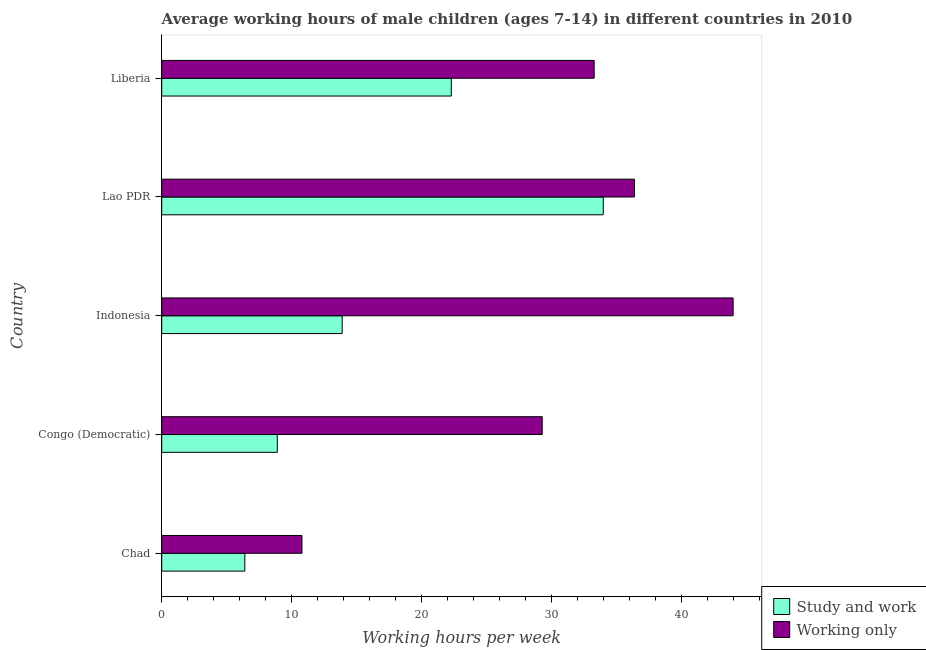How many different coloured bars are there?
Provide a succinct answer. 2. How many bars are there on the 4th tick from the top?
Make the answer very short. 2. How many bars are there on the 2nd tick from the bottom?
Your response must be concise. 2. What is the label of the 5th group of bars from the top?
Your answer should be very brief. Chad. What is the average working hour of children involved in only work in Chad?
Provide a succinct answer. 10.8. Across all countries, what is the minimum average working hour of children involved in only work?
Your response must be concise. 10.8. In which country was the average working hour of children involved in study and work maximum?
Make the answer very short. Lao PDR. In which country was the average working hour of children involved in study and work minimum?
Give a very brief answer. Chad. What is the total average working hour of children involved in study and work in the graph?
Your answer should be very brief. 85.5. What is the difference between the average working hour of children involved in study and work in Chad and that in Liberia?
Give a very brief answer. -15.9. What is the difference between the average working hour of children involved in only work in Congo (Democratic) and the average working hour of children involved in study and work in Indonesia?
Make the answer very short. 15.4. What is the average average working hour of children involved in only work per country?
Your answer should be compact. 30.76. What is the difference between the average working hour of children involved in only work and average working hour of children involved in study and work in Indonesia?
Ensure brevity in your answer.  30.1. In how many countries, is the average working hour of children involved in only work greater than 42 hours?
Give a very brief answer. 1. What is the ratio of the average working hour of children involved in study and work in Chad to that in Liberia?
Offer a very short reply. 0.29. Is the average working hour of children involved in study and work in Congo (Democratic) less than that in Indonesia?
Offer a very short reply. Yes. What is the difference between the highest and the lowest average working hour of children involved in only work?
Make the answer very short. 33.2. In how many countries, is the average working hour of children involved in only work greater than the average average working hour of children involved in only work taken over all countries?
Your answer should be very brief. 3. What does the 2nd bar from the top in Lao PDR represents?
Provide a short and direct response. Study and work. What does the 2nd bar from the bottom in Congo (Democratic) represents?
Make the answer very short. Working only. How many bars are there?
Make the answer very short. 10. What is the difference between two consecutive major ticks on the X-axis?
Provide a succinct answer. 10. Are the values on the major ticks of X-axis written in scientific E-notation?
Make the answer very short. No. Does the graph contain any zero values?
Provide a succinct answer. No. Does the graph contain grids?
Offer a terse response. No. What is the title of the graph?
Ensure brevity in your answer.  Average working hours of male children (ages 7-14) in different countries in 2010. Does "Methane" appear as one of the legend labels in the graph?
Make the answer very short. No. What is the label or title of the X-axis?
Give a very brief answer. Working hours per week. What is the Working hours per week of Study and work in Chad?
Keep it short and to the point. 6.4. What is the Working hours per week in Working only in Chad?
Your response must be concise. 10.8. What is the Working hours per week of Working only in Congo (Democratic)?
Your answer should be very brief. 29.3. What is the Working hours per week in Working only in Indonesia?
Your response must be concise. 44. What is the Working hours per week in Working only in Lao PDR?
Your response must be concise. 36.4. What is the Working hours per week in Study and work in Liberia?
Offer a very short reply. 22.3. What is the Working hours per week in Working only in Liberia?
Make the answer very short. 33.3. Across all countries, what is the minimum Working hours per week in Study and work?
Provide a short and direct response. 6.4. What is the total Working hours per week in Study and work in the graph?
Keep it short and to the point. 85.5. What is the total Working hours per week in Working only in the graph?
Provide a short and direct response. 153.8. What is the difference between the Working hours per week of Working only in Chad and that in Congo (Democratic)?
Offer a very short reply. -18.5. What is the difference between the Working hours per week in Study and work in Chad and that in Indonesia?
Your response must be concise. -7.5. What is the difference between the Working hours per week of Working only in Chad and that in Indonesia?
Your answer should be compact. -33.2. What is the difference between the Working hours per week in Study and work in Chad and that in Lao PDR?
Ensure brevity in your answer.  -27.6. What is the difference between the Working hours per week of Working only in Chad and that in Lao PDR?
Offer a terse response. -25.6. What is the difference between the Working hours per week in Study and work in Chad and that in Liberia?
Make the answer very short. -15.9. What is the difference between the Working hours per week of Working only in Chad and that in Liberia?
Your answer should be compact. -22.5. What is the difference between the Working hours per week of Study and work in Congo (Democratic) and that in Indonesia?
Offer a terse response. -5. What is the difference between the Working hours per week of Working only in Congo (Democratic) and that in Indonesia?
Ensure brevity in your answer.  -14.7. What is the difference between the Working hours per week of Study and work in Congo (Democratic) and that in Lao PDR?
Ensure brevity in your answer.  -25.1. What is the difference between the Working hours per week in Working only in Congo (Democratic) and that in Lao PDR?
Offer a very short reply. -7.1. What is the difference between the Working hours per week in Study and work in Congo (Democratic) and that in Liberia?
Your answer should be compact. -13.4. What is the difference between the Working hours per week in Study and work in Indonesia and that in Lao PDR?
Your response must be concise. -20.1. What is the difference between the Working hours per week of Working only in Indonesia and that in Lao PDR?
Your answer should be compact. 7.6. What is the difference between the Working hours per week of Working only in Indonesia and that in Liberia?
Your answer should be compact. 10.7. What is the difference between the Working hours per week of Study and work in Lao PDR and that in Liberia?
Your response must be concise. 11.7. What is the difference between the Working hours per week of Study and work in Chad and the Working hours per week of Working only in Congo (Democratic)?
Your response must be concise. -22.9. What is the difference between the Working hours per week in Study and work in Chad and the Working hours per week in Working only in Indonesia?
Give a very brief answer. -37.6. What is the difference between the Working hours per week in Study and work in Chad and the Working hours per week in Working only in Lao PDR?
Make the answer very short. -30. What is the difference between the Working hours per week in Study and work in Chad and the Working hours per week in Working only in Liberia?
Keep it short and to the point. -26.9. What is the difference between the Working hours per week in Study and work in Congo (Democratic) and the Working hours per week in Working only in Indonesia?
Your answer should be compact. -35.1. What is the difference between the Working hours per week of Study and work in Congo (Democratic) and the Working hours per week of Working only in Lao PDR?
Offer a terse response. -27.5. What is the difference between the Working hours per week of Study and work in Congo (Democratic) and the Working hours per week of Working only in Liberia?
Offer a very short reply. -24.4. What is the difference between the Working hours per week of Study and work in Indonesia and the Working hours per week of Working only in Lao PDR?
Offer a very short reply. -22.5. What is the difference between the Working hours per week in Study and work in Indonesia and the Working hours per week in Working only in Liberia?
Your answer should be very brief. -19.4. What is the average Working hours per week of Working only per country?
Keep it short and to the point. 30.76. What is the difference between the Working hours per week of Study and work and Working hours per week of Working only in Congo (Democratic)?
Provide a succinct answer. -20.4. What is the difference between the Working hours per week of Study and work and Working hours per week of Working only in Indonesia?
Your answer should be very brief. -30.1. What is the ratio of the Working hours per week of Study and work in Chad to that in Congo (Democratic)?
Ensure brevity in your answer.  0.72. What is the ratio of the Working hours per week of Working only in Chad to that in Congo (Democratic)?
Make the answer very short. 0.37. What is the ratio of the Working hours per week of Study and work in Chad to that in Indonesia?
Keep it short and to the point. 0.46. What is the ratio of the Working hours per week of Working only in Chad to that in Indonesia?
Provide a succinct answer. 0.25. What is the ratio of the Working hours per week in Study and work in Chad to that in Lao PDR?
Offer a very short reply. 0.19. What is the ratio of the Working hours per week in Working only in Chad to that in Lao PDR?
Offer a very short reply. 0.3. What is the ratio of the Working hours per week in Study and work in Chad to that in Liberia?
Make the answer very short. 0.29. What is the ratio of the Working hours per week in Working only in Chad to that in Liberia?
Your answer should be compact. 0.32. What is the ratio of the Working hours per week of Study and work in Congo (Democratic) to that in Indonesia?
Provide a succinct answer. 0.64. What is the ratio of the Working hours per week in Working only in Congo (Democratic) to that in Indonesia?
Give a very brief answer. 0.67. What is the ratio of the Working hours per week in Study and work in Congo (Democratic) to that in Lao PDR?
Offer a terse response. 0.26. What is the ratio of the Working hours per week in Working only in Congo (Democratic) to that in Lao PDR?
Keep it short and to the point. 0.8. What is the ratio of the Working hours per week of Study and work in Congo (Democratic) to that in Liberia?
Make the answer very short. 0.4. What is the ratio of the Working hours per week of Working only in Congo (Democratic) to that in Liberia?
Provide a succinct answer. 0.88. What is the ratio of the Working hours per week of Study and work in Indonesia to that in Lao PDR?
Offer a very short reply. 0.41. What is the ratio of the Working hours per week of Working only in Indonesia to that in Lao PDR?
Offer a terse response. 1.21. What is the ratio of the Working hours per week of Study and work in Indonesia to that in Liberia?
Provide a succinct answer. 0.62. What is the ratio of the Working hours per week in Working only in Indonesia to that in Liberia?
Keep it short and to the point. 1.32. What is the ratio of the Working hours per week in Study and work in Lao PDR to that in Liberia?
Keep it short and to the point. 1.52. What is the ratio of the Working hours per week of Working only in Lao PDR to that in Liberia?
Keep it short and to the point. 1.09. What is the difference between the highest and the second highest Working hours per week in Working only?
Your answer should be compact. 7.6. What is the difference between the highest and the lowest Working hours per week in Study and work?
Your response must be concise. 27.6. What is the difference between the highest and the lowest Working hours per week of Working only?
Make the answer very short. 33.2. 